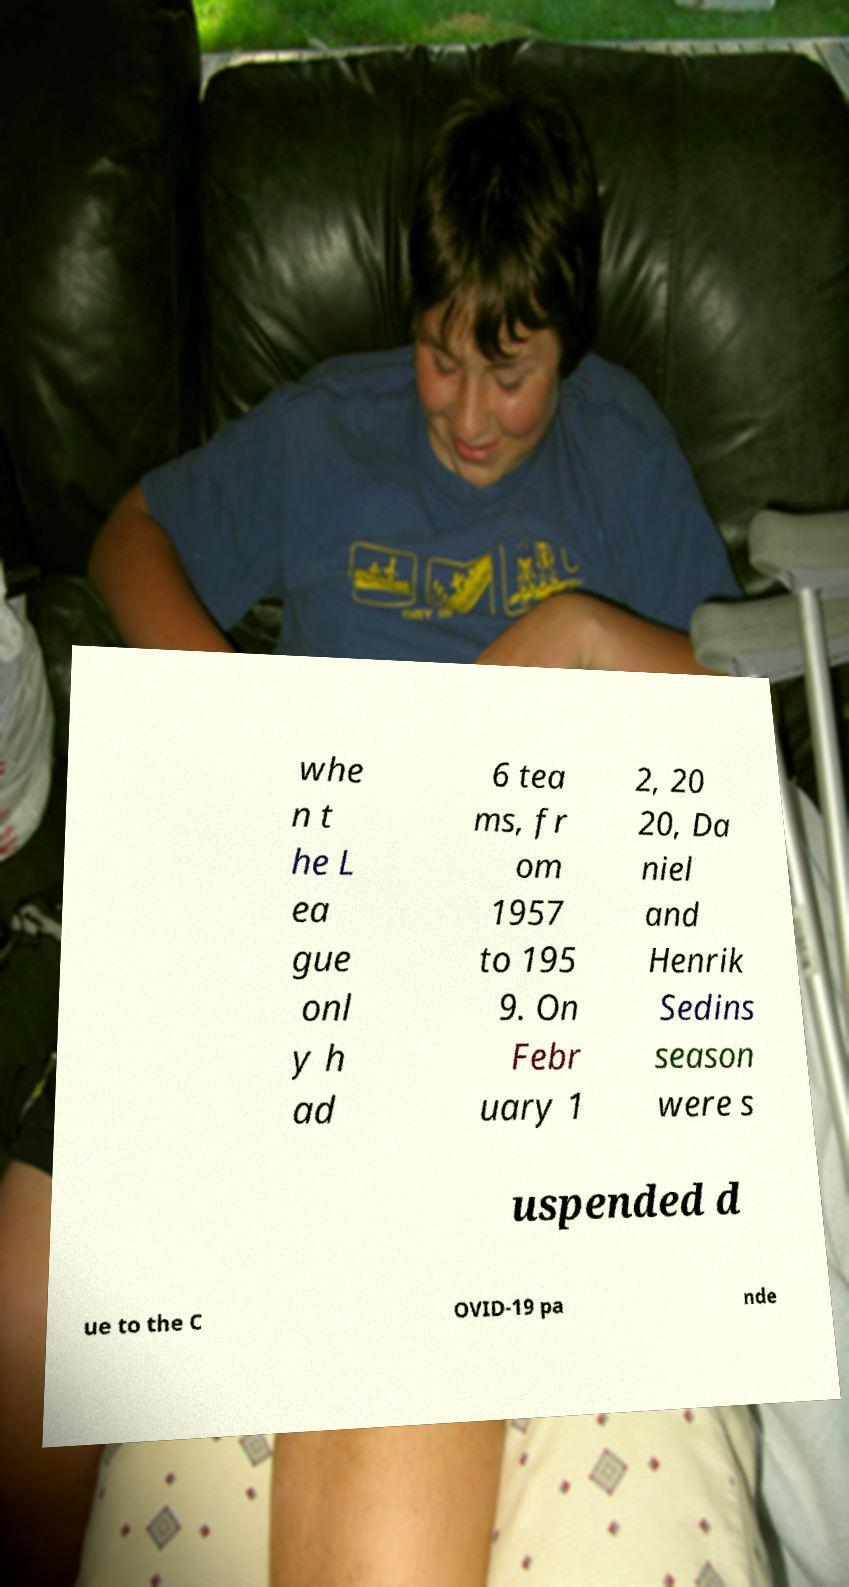Please identify and transcribe the text found in this image. whe n t he L ea gue onl y h ad 6 tea ms, fr om 1957 to 195 9. On Febr uary 1 2, 20 20, Da niel and Henrik Sedins season were s uspended d ue to the C OVID-19 pa nde 